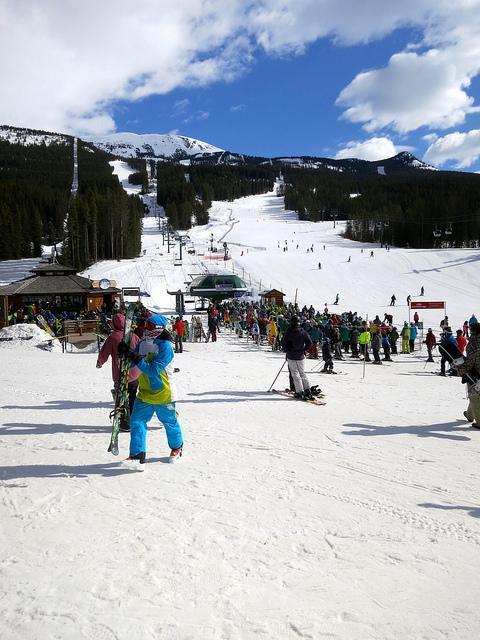How many people are there?
Give a very brief answer. 2. 